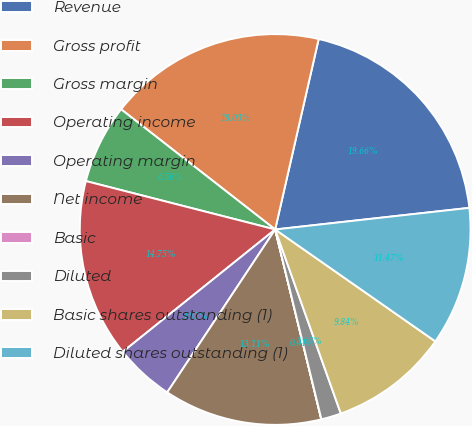Convert chart to OTSL. <chart><loc_0><loc_0><loc_500><loc_500><pie_chart><fcel>Revenue<fcel>Gross profit<fcel>Gross margin<fcel>Operating income<fcel>Operating margin<fcel>Net income<fcel>Basic<fcel>Diluted<fcel>Basic shares outstanding (1)<fcel>Diluted shares outstanding (1)<nl><fcel>19.66%<fcel>18.03%<fcel>6.56%<fcel>14.75%<fcel>4.92%<fcel>13.11%<fcel>0.01%<fcel>1.65%<fcel>9.84%<fcel>11.47%<nl></chart> 